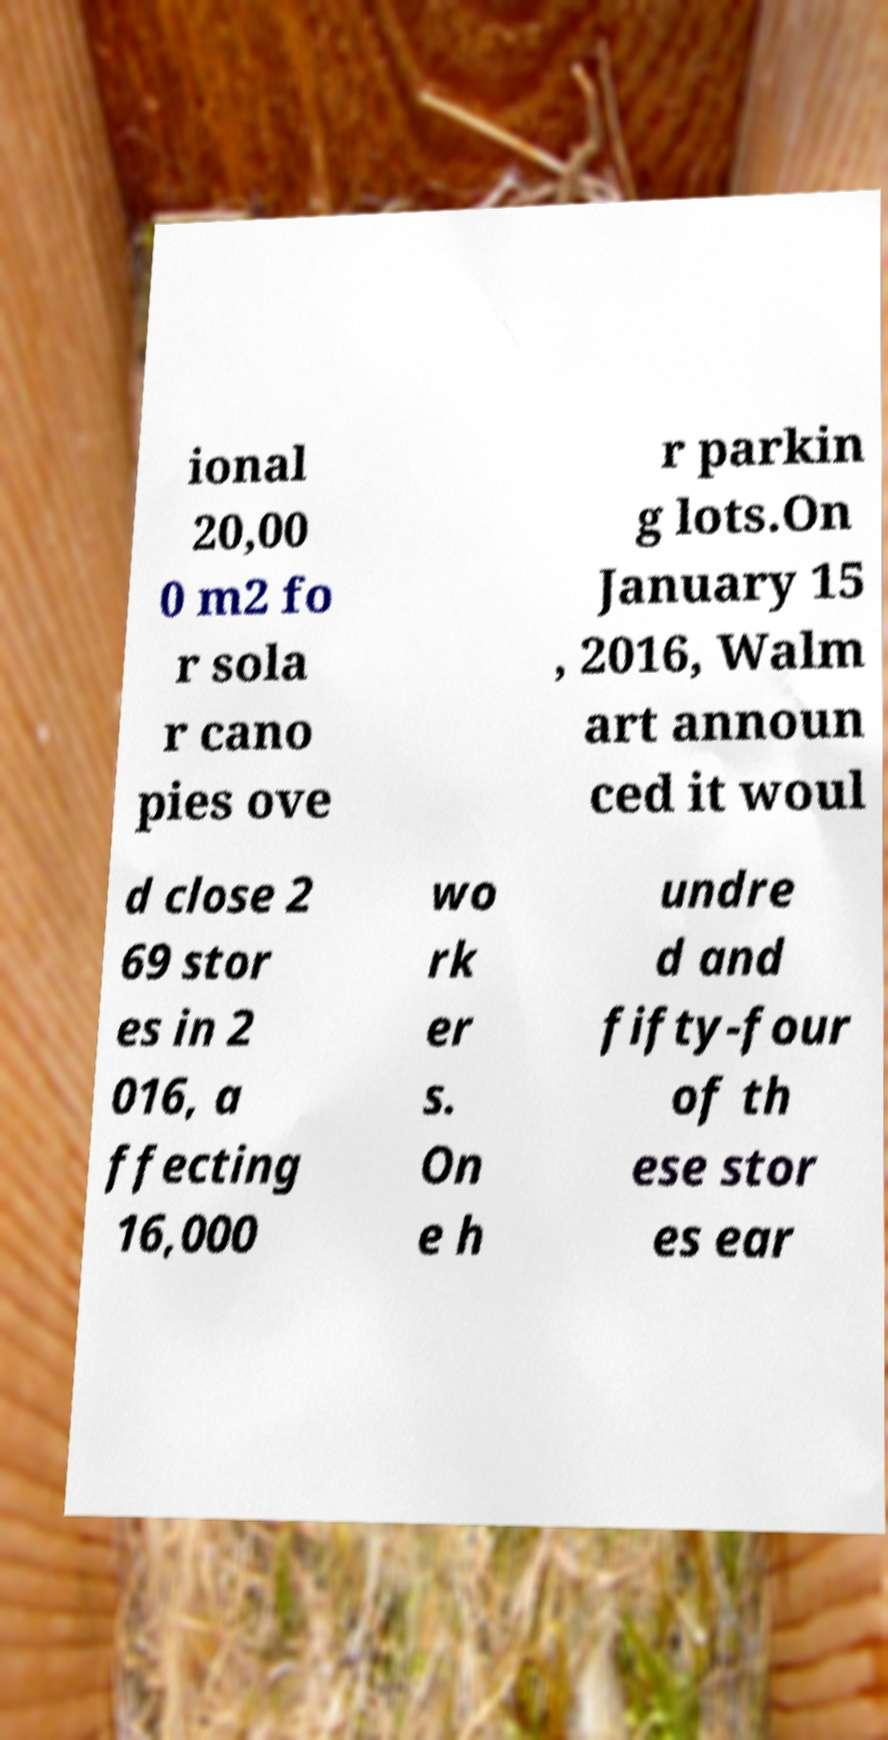There's text embedded in this image that I need extracted. Can you transcribe it verbatim? ional 20,00 0 m2 fo r sola r cano pies ove r parkin g lots.On January 15 , 2016, Walm art announ ced it woul d close 2 69 stor es in 2 016, a ffecting 16,000 wo rk er s. On e h undre d and fifty-four of th ese stor es ear 